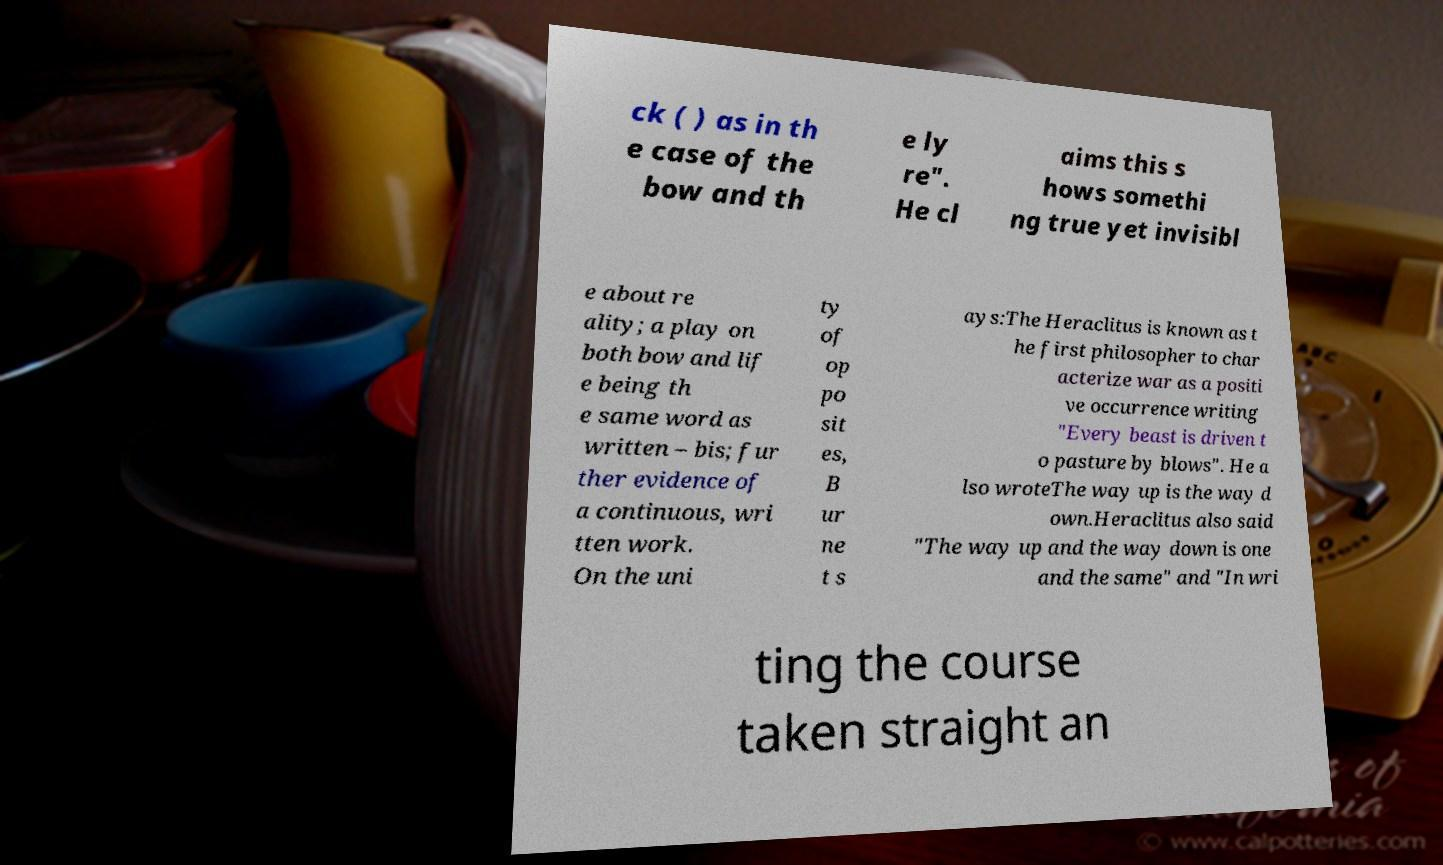I need the written content from this picture converted into text. Can you do that? ck ( ) as in th e case of the bow and th e ly re". He cl aims this s hows somethi ng true yet invisibl e about re ality; a play on both bow and lif e being th e same word as written – bis; fur ther evidence of a continuous, wri tten work. On the uni ty of op po sit es, B ur ne t s ays:The Heraclitus is known as t he first philosopher to char acterize war as a positi ve occurrence writing "Every beast is driven t o pasture by blows". He a lso wroteThe way up is the way d own.Heraclitus also said "The way up and the way down is one and the same" and "In wri ting the course taken straight an 